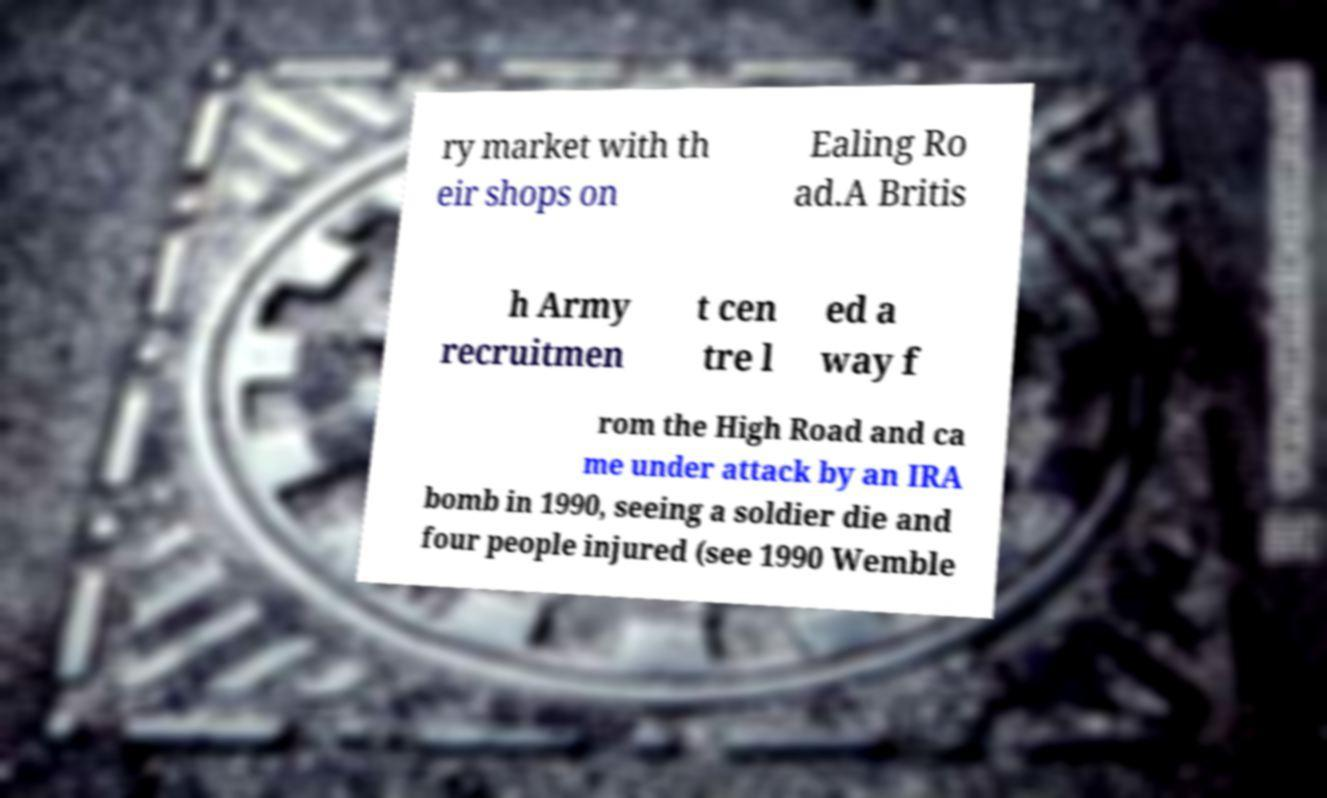What messages or text are displayed in this image? I need them in a readable, typed format. ry market with th eir shops on Ealing Ro ad.A Britis h Army recruitmen t cen tre l ed a way f rom the High Road and ca me under attack by an IRA bomb in 1990, seeing a soldier die and four people injured (see 1990 Wemble 